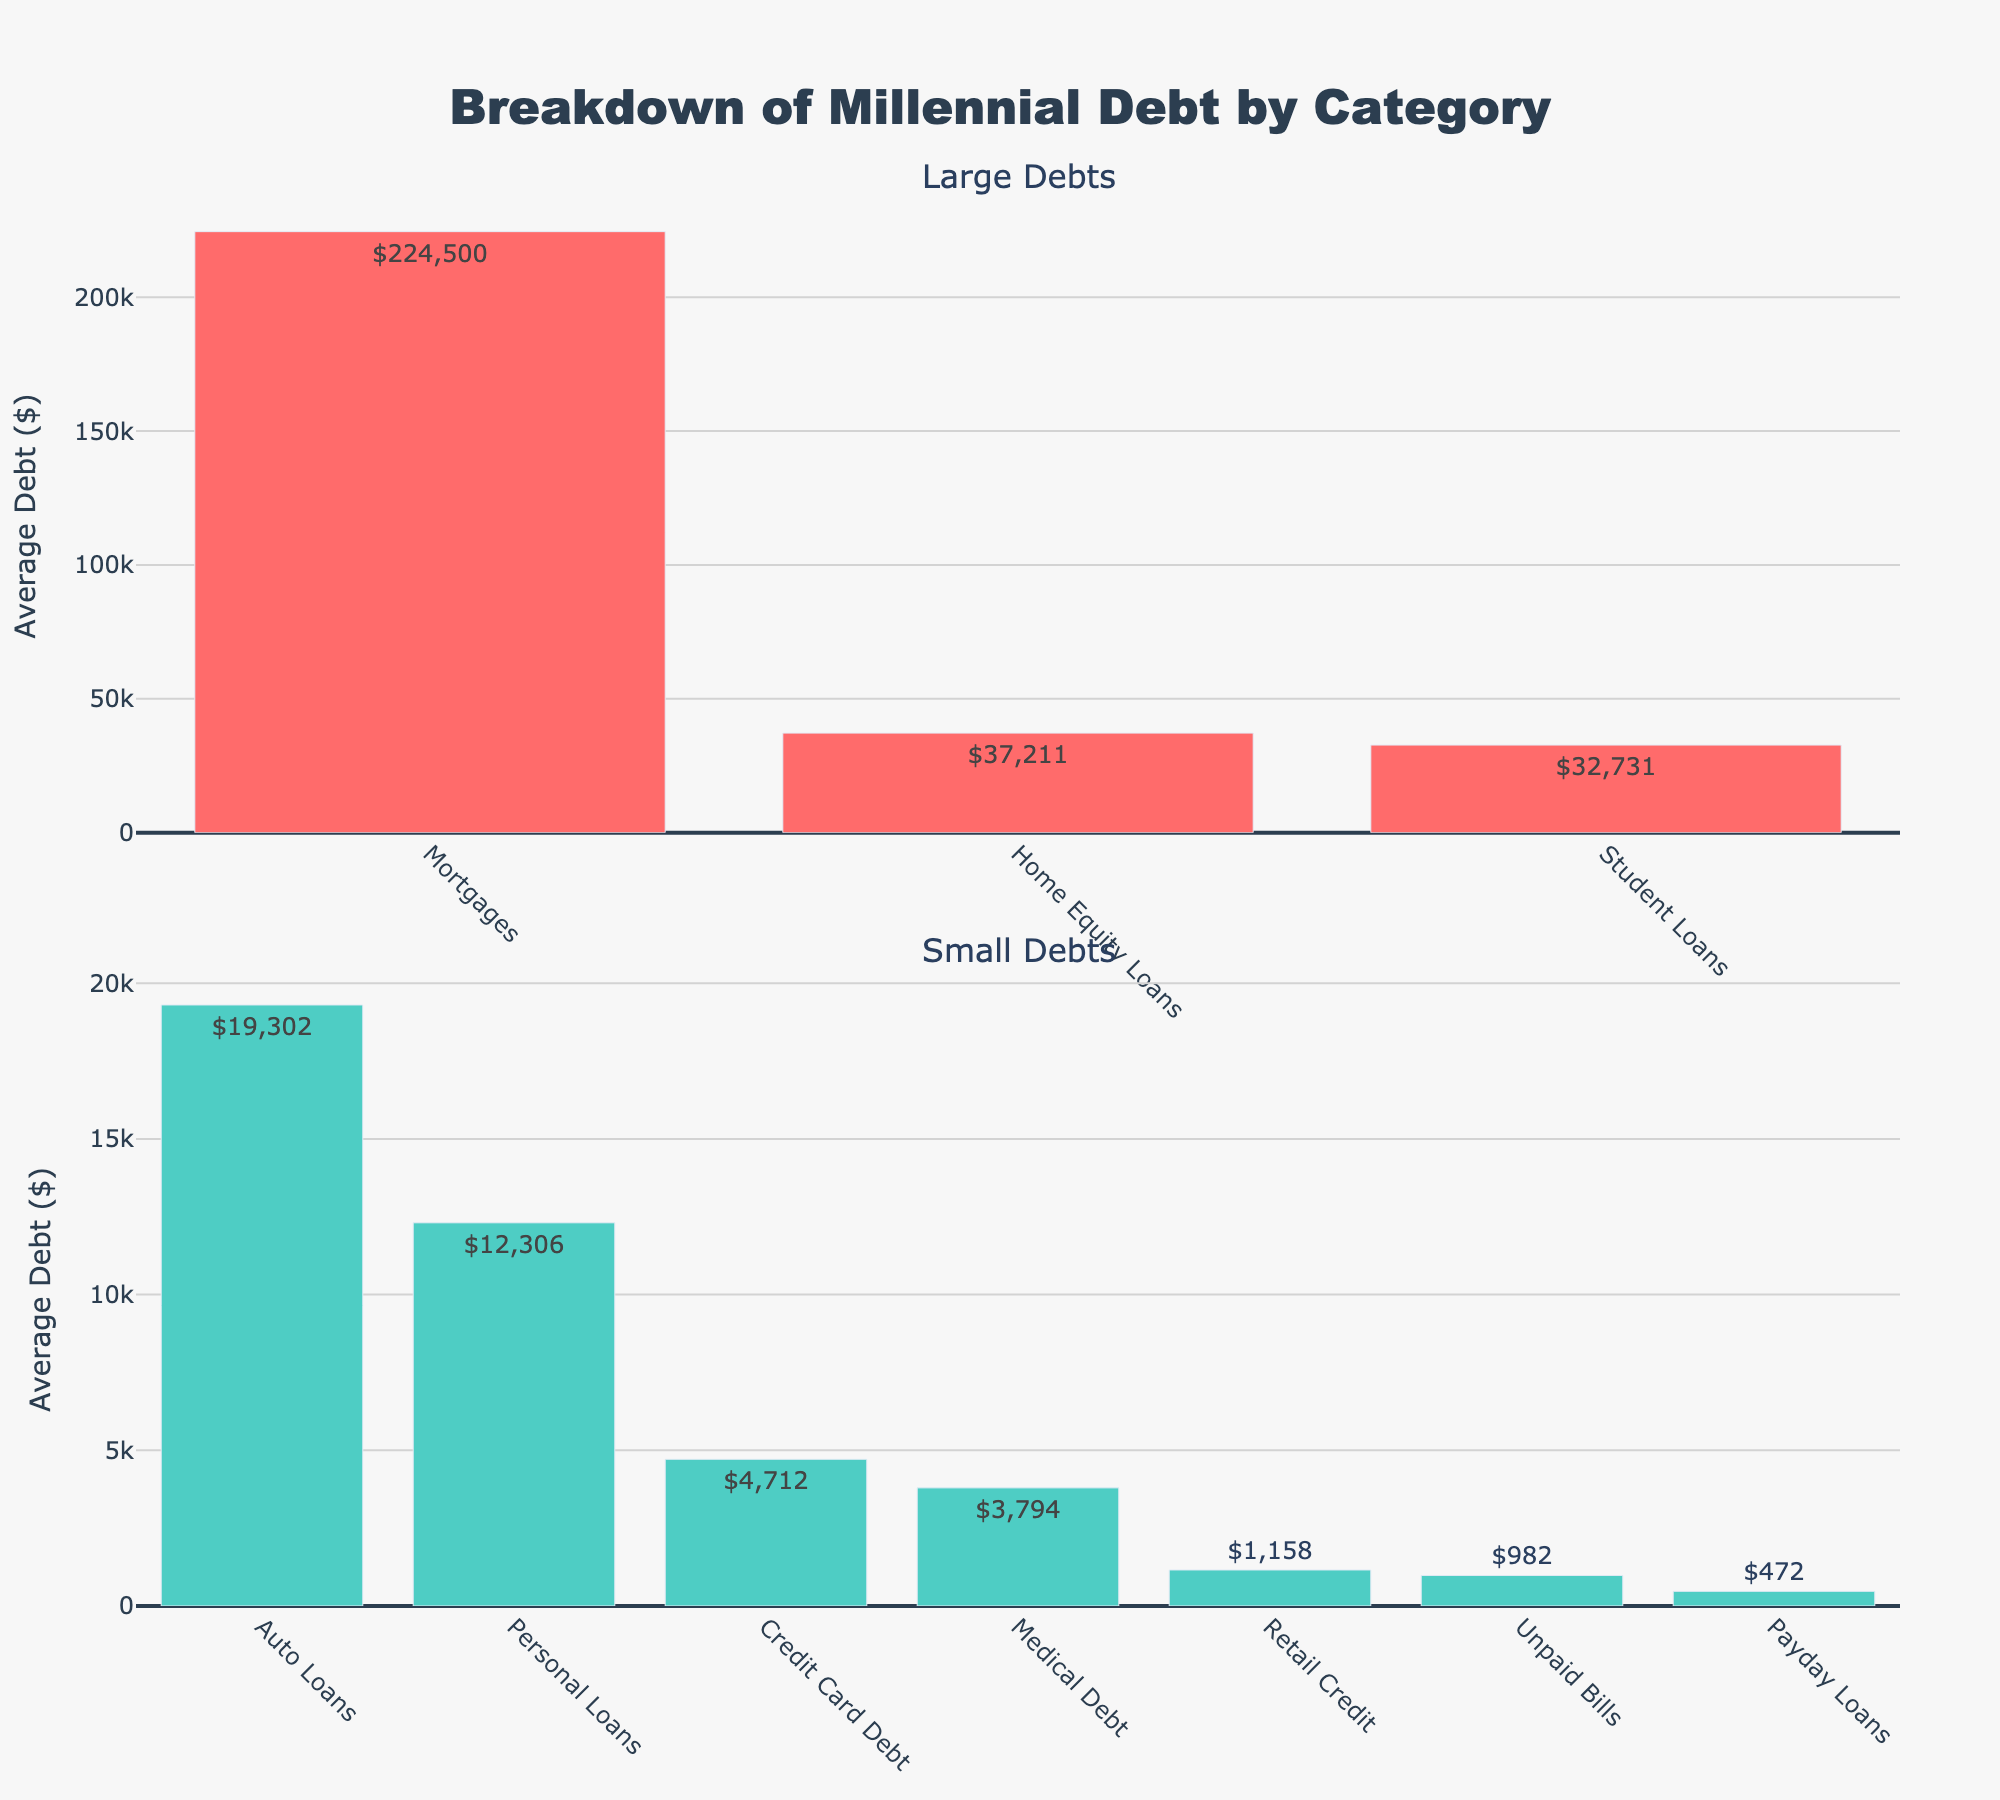What's the largest category of debt for millennials? The largest category of debt can be found by identifying the tallest bar in the "Large Debts" subplot. The tallest bar represents the category with the highest average debt. In the figure, the tallest bar belongs to "Mortgages".
Answer: Mortgages Which is higher: credit card debt or auto loans? To compare the average debt amounts, refer to the "Small Debts" subplot for credit card debt and the "Large Debts" subplot for auto loans. Auto loans have an average debt of $19,302, whereas credit card debt has an average debt of $4,712.
Answer: Auto loans What's the total average debt for categories exceeding $20,000? Identify and sum the average debt of categories with debts more than $20,000, listed in the "Large Debts" subplot. These categories are Mortgages ($224,500), Home Equity Loans ($37,211), and Student Loans ($32,731). Total = $224,500 + $37,211 + $32,731
Answer: $294,442 Which category has a lower average debt, medical debt or retail credit? To determine which category has a lower average debt, compare the bars for medical debt and retail credit in the "Small Debts" subplot. Medical debt has an average debt of $3,794, and retail credit has $1,158.
Answer: Retail credit What is the difference between the highest and lowest average debt amounts? Find the highest average debt (Mortgages: $224,500) and the lowest average debt (Payday Loans: $472). Calculate the difference: $224,500 - $472 = $224,028.
Answer: $224,028 What's the combined average debt for personal loans and unpaid bills? Refer to the "Small Debts" subplot. Personal loans have an average debt of $12,306 and unpaid bills have $982. Add these amounts together: $12,306 + $982 = $13,288.
Answer: $13,288 Rank the categories in the "Large Debts" subplot from highest to lowest. The categories listed in the "Large Debts" subplot, ranked from highest to lowest average debts, are: Mortgages ($224,500), Home Equity Loans ($37,211), Student Loans ($32,731), Auto Loans ($19,302).
Answer: Mortgages, Home Equity Loans, Student Loans, Auto Loans Is the average debt for auto loans closer to that of student loans or personal loans? Compare the average debt of auto loans ($19,302) with student loans ($32,731) and personal loans ($12,306). Calculate the difference: Auto Loans & Student Loans: $32,731 - $19,302 = $13,429; Auto Loans & Personal Loans: $19,302 - $12,306 = $6,996. Auto loans are closer to personal loans.
Answer: Personal loans 